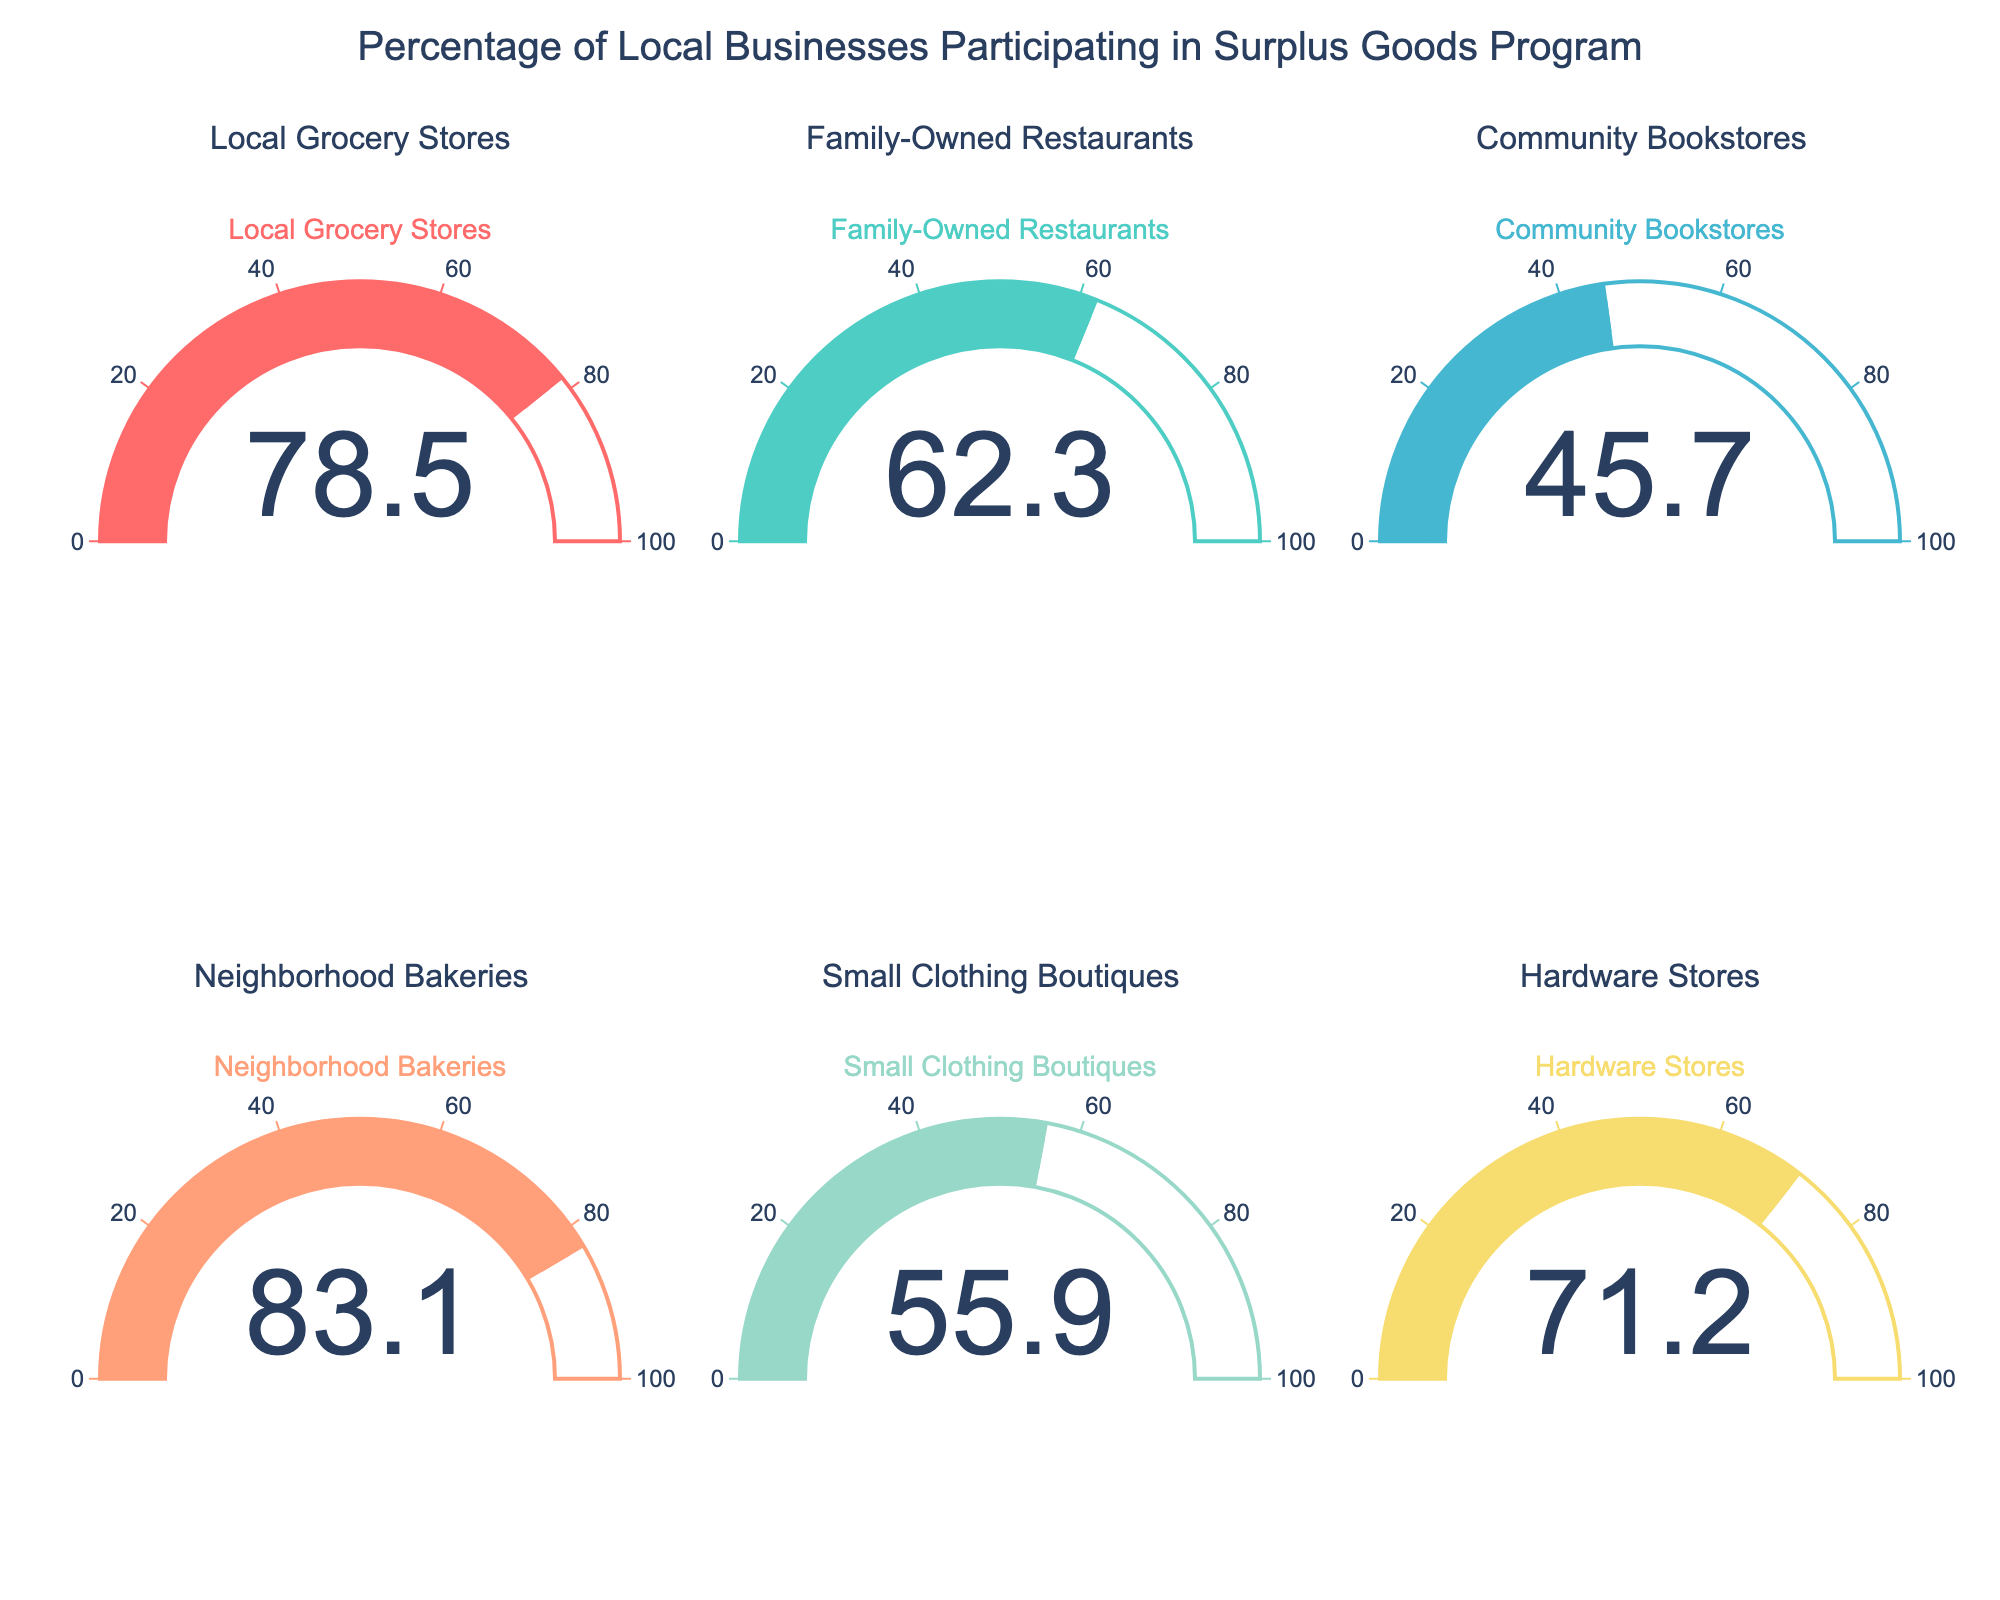what is the participation rate for Neighborhood Bakeries? The figure contains individual gauge charts for different business types, where Neighborhood Bakeries is listed. By observing the corresponding gauge chart, we can see the participation rate.
Answer: 83.1% Which business type has the highest participation rate? By comparing the values displayed on each gauge chart, we can identify the highest participation rate. The Neighborhood Bakeries have the highest participation rate shown on the gauge chart.
Answer: Neighborhood Bakeries Are there more businesses with participation rates above 70% or below 70%? By examining each gauge chart and counting businesses with participation rates above and below 70%, we can then compare the totals. There are four businesses above 70% and two below 70%.
Answer: Above 70% What is the combined participation rate of Local Grocery Stores and Hardware Stores? The participation rate for Local Grocery Stores is 78.5, and for Hardware Stores, it's 71.2. To find the combined participation rate, we sum these two values.
Answer: 149.7 Which business type shows the smallest participation rate, and how does it compare to the highest rate? The smallest rate can be found by identifying the gauge chart with the lowest value, which is Community Bookstores at 45.7%. Then, compare this to the highest rate, Neighborhood Bakeries at 83.1%, by calculating the difference.
Answer: The smallest rate is 45.7% (Community Bookstores). The difference is 83.1% - 45.7% = 37.4% What is the average participation rate across the six business types? To find the average, sum all the participation rates: 78.5 + 62.3 + 45.7 + 83.1 + 55.9 + 71.2, and then divide by the number of business types (6).
Answer: 66.12% How does the participation rate of Family-Owned Restaurants compare to Small Clothing Boutiques? Check the gauge charts for Family-Owned Restaurants (62.3) and Small Clothing Boutiques (55.9), then find the difference between the two values.
Answer: Family-Owned Restaurants have a higher rate by 6.4% Which business type has a participation rate closest to the mean participation rate of all business types? First, calculate the mean participation rate: (78.5 + 62.3 + 45.7 + 83.1 + 55.9 + 71.2) / 6 = 66.12. Then, compare each participation rate to find the one closest to 66.12.
Answer: Hardware Stores 